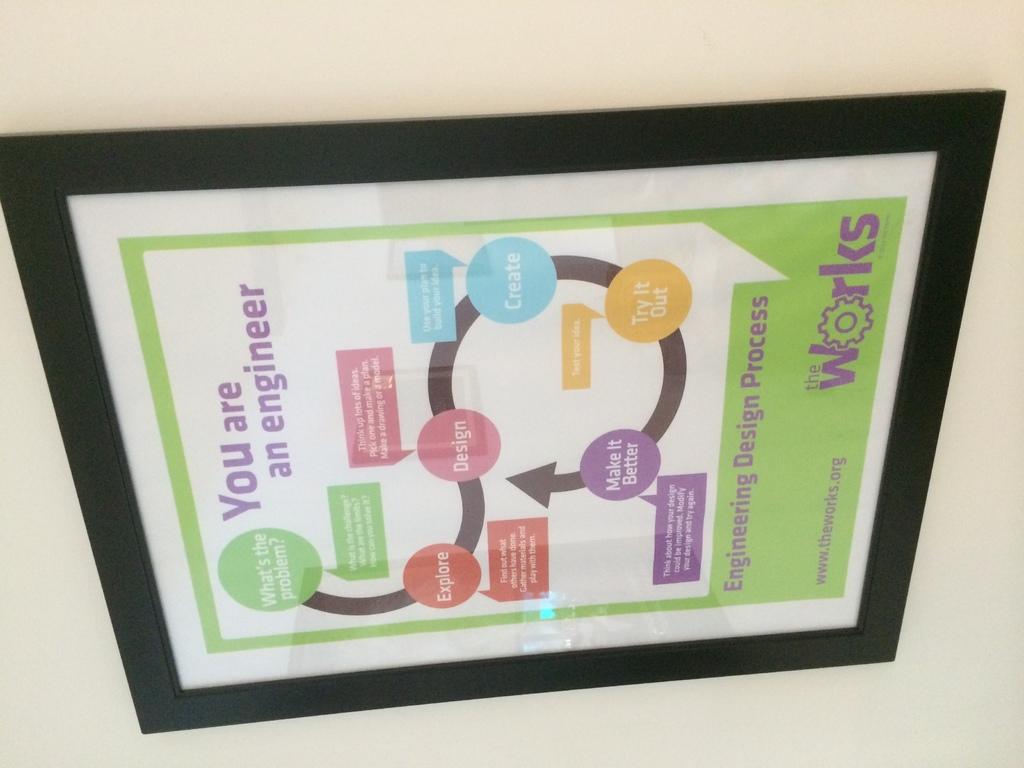What profession does it say you are?
Your response must be concise. Engineer. 